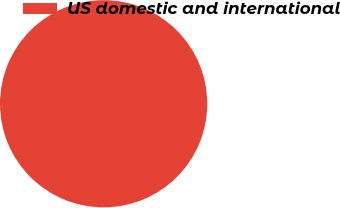Convert chart to OTSL. <chart><loc_0><loc_0><loc_500><loc_500><pie_chart><fcel>US domestic and international<nl><fcel>100.0%<nl></chart> 